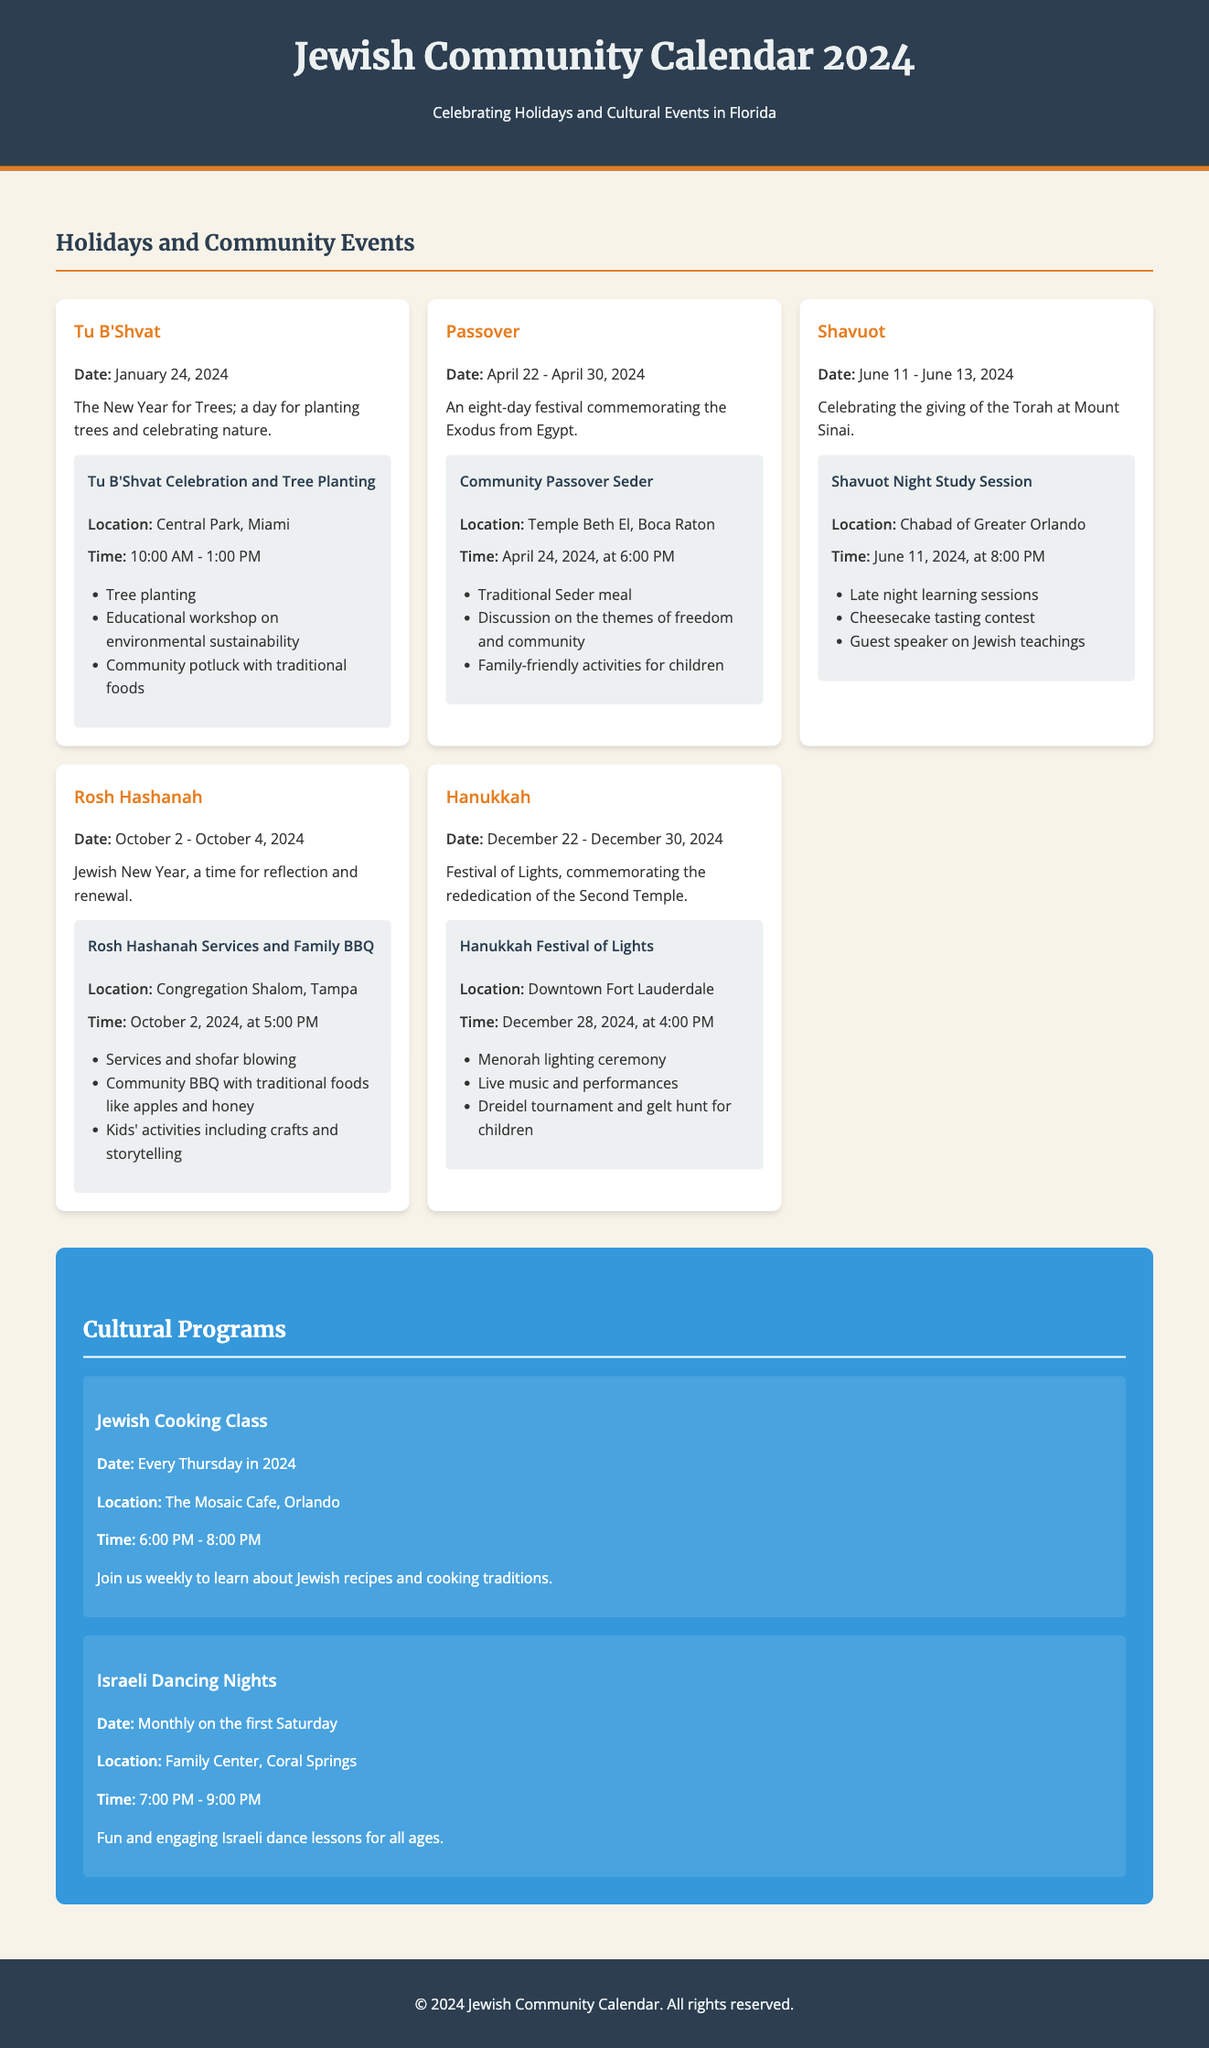What is the date of Tu B'Shvat? The date of Tu B'Shvat is mentioned as January 24, 2024.
Answer: January 24, 2024 Where is the Community Passover Seder taking place? The location of the Community Passover Seder is given as Temple Beth El, Boca Raton.
Answer: Temple Beth El, Boca Raton What event occurs on April 24, 2024? April 24, 2024, is the date for the Community Passover Seder.
Answer: Community Passover Seder How many days does Hanukkah last in 2024? The document states that Hanukkah lasts from December 22 to December 30, 2024, which is a total of 8 days.
Answer: 8 days What is the theme of the Shavuot Night Study Session? The document indicates that the theme includes late-night learning sessions and a guest speaker on Jewish teachings.
Answer: Late-night learning sessions When do the Jewish Cooking Classes occur? The document specifies that Jewish Cooking Classes take place every Thursday in 2024.
Answer: Every Thursday in 2024 Which community event includes a Menorah lighting ceremony? The Hanukkah Festival of Lights includes a Menorah lighting ceremony as part of the event details.
Answer: Hanukkah Festival of Lights What type of activities are included for children during Rosh Hashanah? The document mentions kids' activities including crafts and storytelling during Rosh Hashanah.
Answer: Crafts and storytelling 